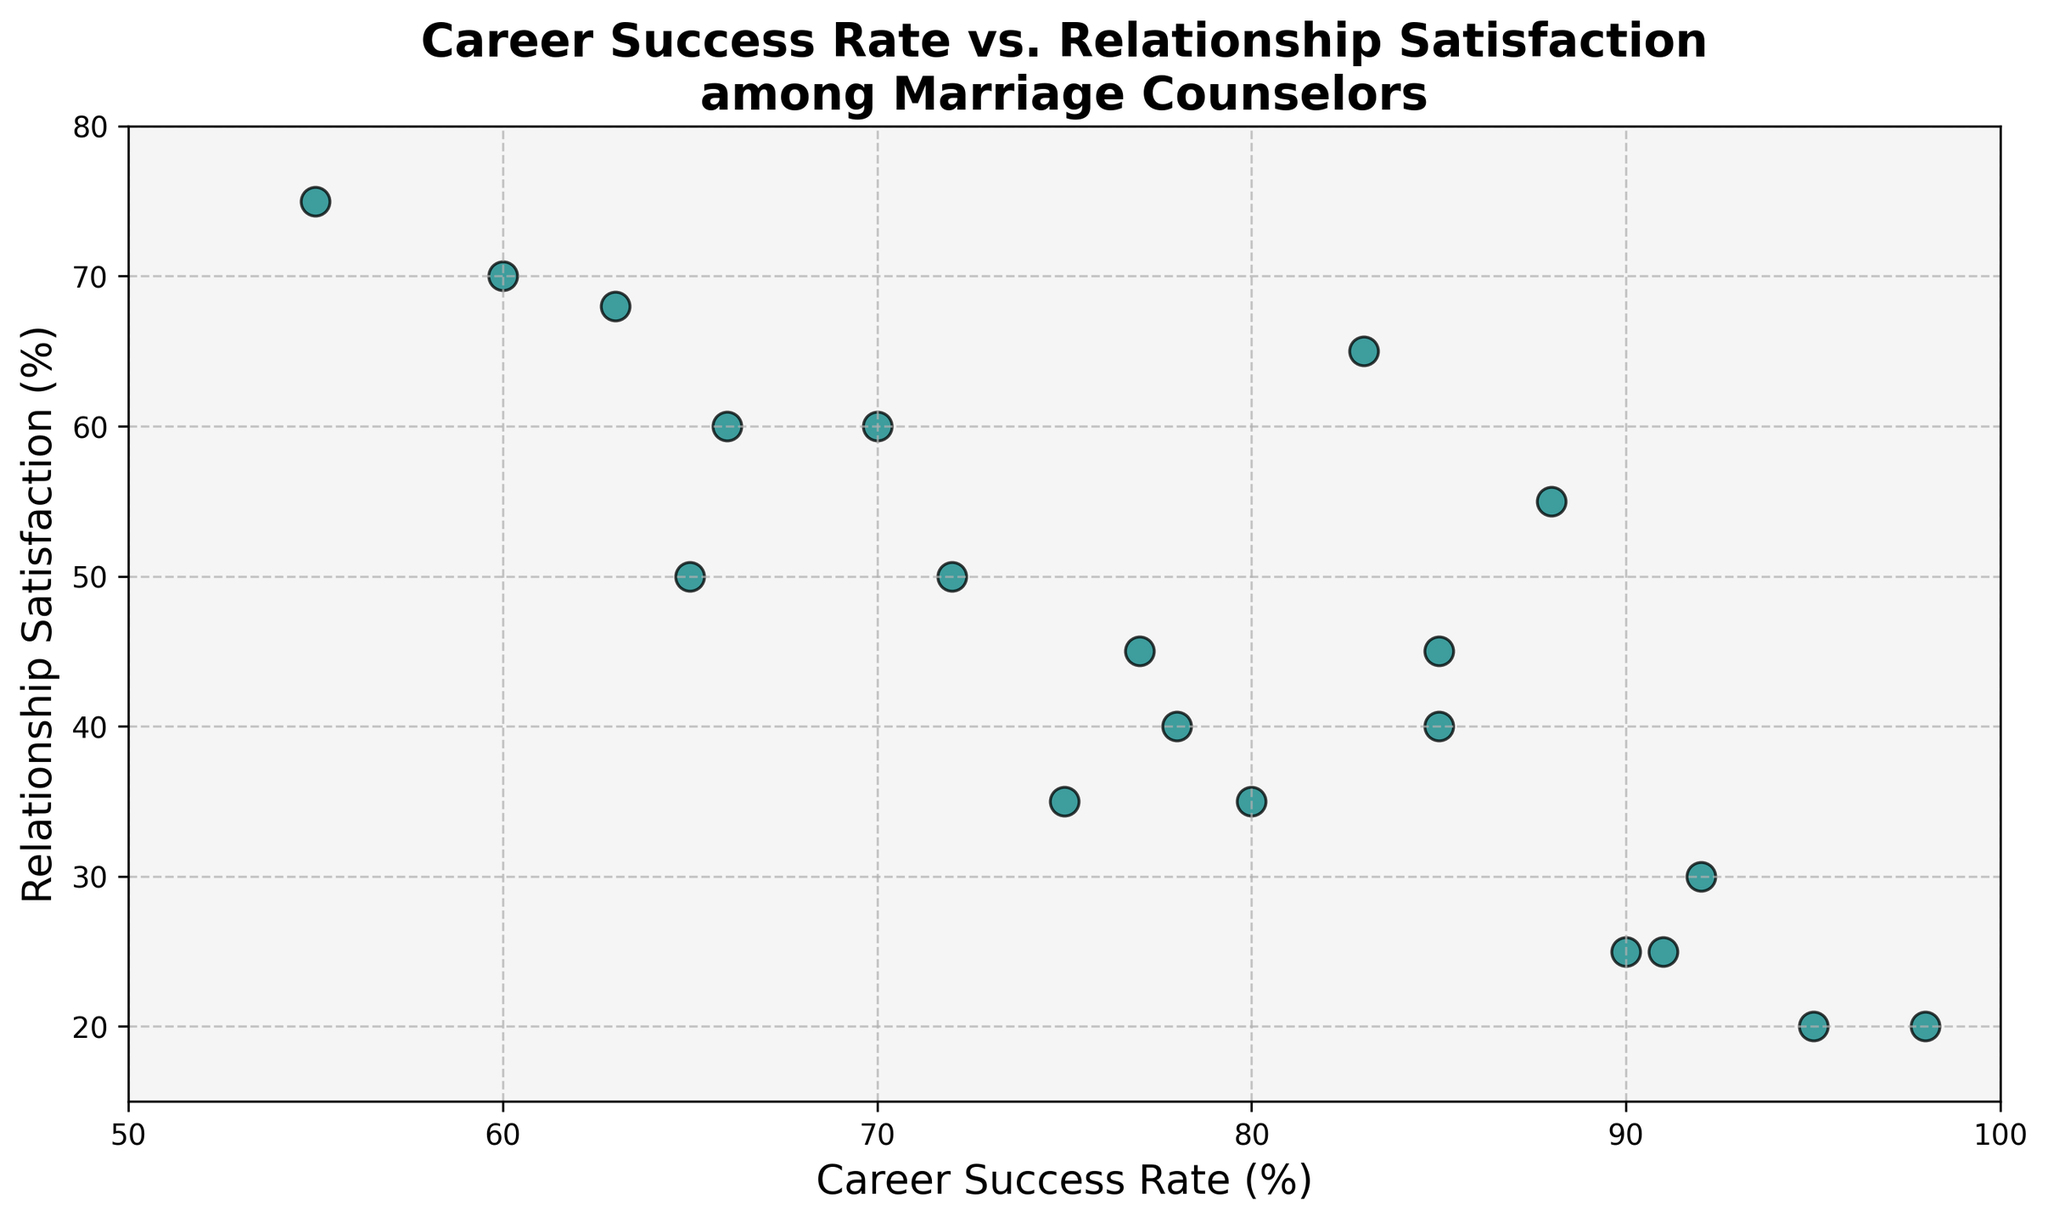What's the relationship between the highest career success rate and the lowest relationship satisfaction? The highest career success rate is 98%, and the corresponding relationship satisfaction is 20%. The lowest relationship satisfaction of 20% appears twice, once with a career success rate of 95% and once with 98%.
Answer: 98% career success rate corresponds with 20% relationship satisfaction Is there a positive correlation between career success rate and relationship satisfaction? Observing the scatter plot shows a tendency where higher career success rates are generally associated with lower relationship satisfaction rates, indicating a negative correlation.
Answer: No, there is a negative correlation What is the relationship satisfaction for a career success rate of 70%? Locate the point with a career success rate of 70% on the X-axis and observe the corresponding Y-axis value, which is 60%.
Answer: 60% How many data points have a career success rate between 70% and 90%, inclusive? Observe the scatter plot to count how many points lie between the X-axis values of 70% to 90%. Points correspond to 70%, 72%, 75%, 77%, 78%, 80%, 83%, 85%, 85%, and 88%.
Answer: 10 What is the average relationship satisfaction for the career success rates of 80% and above? Identify the points with a career success rate of 80% and above (80%, 83%, 85%, 85%, 88%, 90%, 91%, 92%, 95%, 98%). Relationship satisfaction values are (35, 65, 45, 40, 55, 25, 25, 30, 20, 20). Summing these (35 + 65 + 45 + 40 + 55 + 25 + 25 + 30 + 20 + 20) gives 360. There are 10 values, so 360/10 results in an average relationship satisfaction of 36%.
Answer: 36% Which data point has the largest difference between career success rate and relationship satisfaction? Calculate the difference for each point: 95-20=75, 80-35=45, 85-45=40, 70-60=10, 90-25=65, 65-50=15, 78-40=38, 92-30=62, 88-55=33, 83-65=18, 60-70=-10, 75-35=40, 98-20=78, 55-75=-20, 72-50=22, 66-60=6, 91-25=66, 77-45=32, 85-40=45, 63-68=-5. The largest difference is 98 (career success rate) - 20 (relationship satisfaction) = 78.
Answer: 78 Which point has the highest relationship satisfaction? Identify the point on the scatter plot with the highest Y-axis value, which is 75%. The corresponding career success rate is 55%.
Answer: 55% career success rate Are there any data points that share the same relationship satisfaction but have different career success rates? Identify points with the same Y-axis value but different X-axis values. Examples include 20% relationship satisfaction for career success rates 95% and 98%, and 25% relationship satisfaction for 90% and 91%.
Answer: Yes, examples are 20% for 95% & 98% career success rates, 25% for 90% & 91% What's the median relationship satisfaction of all data points? List relationship satisfaction values in ascending order: 20, 20, 20, 25, 25, 30, 35, 35, 40, 40, 45, 45, 50, 50, 55, 60, 60, 65, 68, 70, 75. With 20 values, the median is the average of the 10th and 11th values (40+40)/2 = 42.5.
Answer: 42.5 